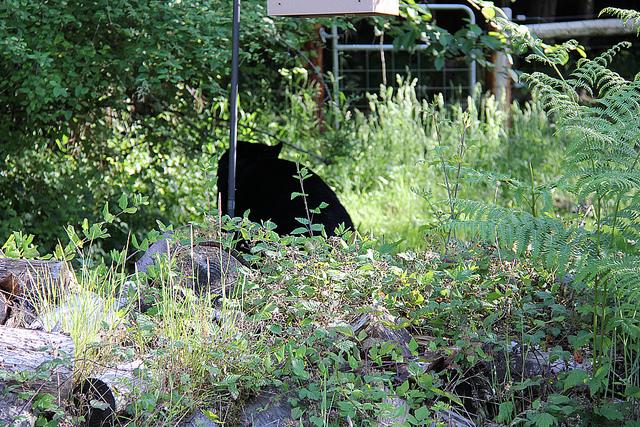Is there a lot of greenery in this area?
Write a very short answer. Yes. What animal is pictured in the center?
Keep it brief. Bear. What color is the cat in the picture?
Quick response, please. Black. 